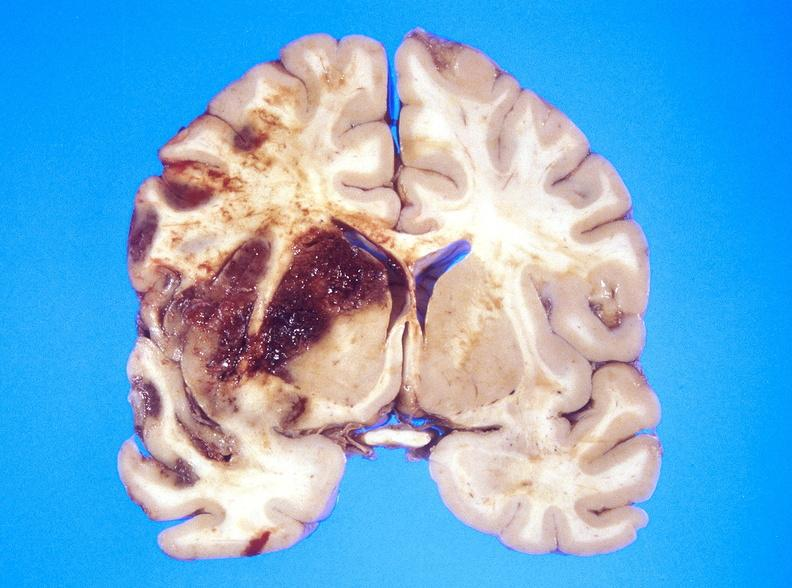does medial aspect show hemorrhagic reperfusion infarct, middle cerebral artery l?
Answer the question using a single word or phrase. No 